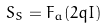<formula> <loc_0><loc_0><loc_500><loc_500>S _ { S } = F _ { a } ( 2 q I )</formula> 